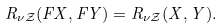<formula> <loc_0><loc_0><loc_500><loc_500>R _ { \nu \mathcal { Z } } ( F X , F Y ) = R _ { \nu \mathcal { Z } } ( X , Y ) .</formula> 